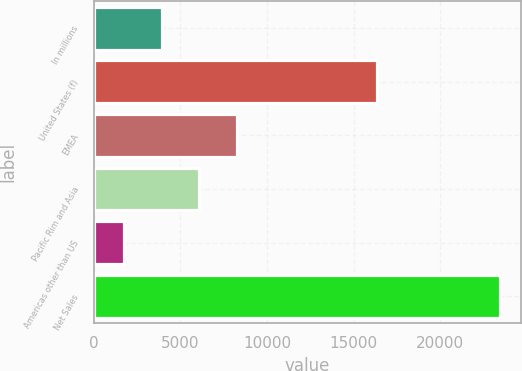<chart> <loc_0><loc_0><loc_500><loc_500><bar_chart><fcel>In millions<fcel>United States (f)<fcel>EMEA<fcel>Pacific Rim and Asia<fcel>Americas other than US<fcel>Net Sales<nl><fcel>3921.5<fcel>16371<fcel>8268.5<fcel>6095<fcel>1748<fcel>23483<nl></chart> 